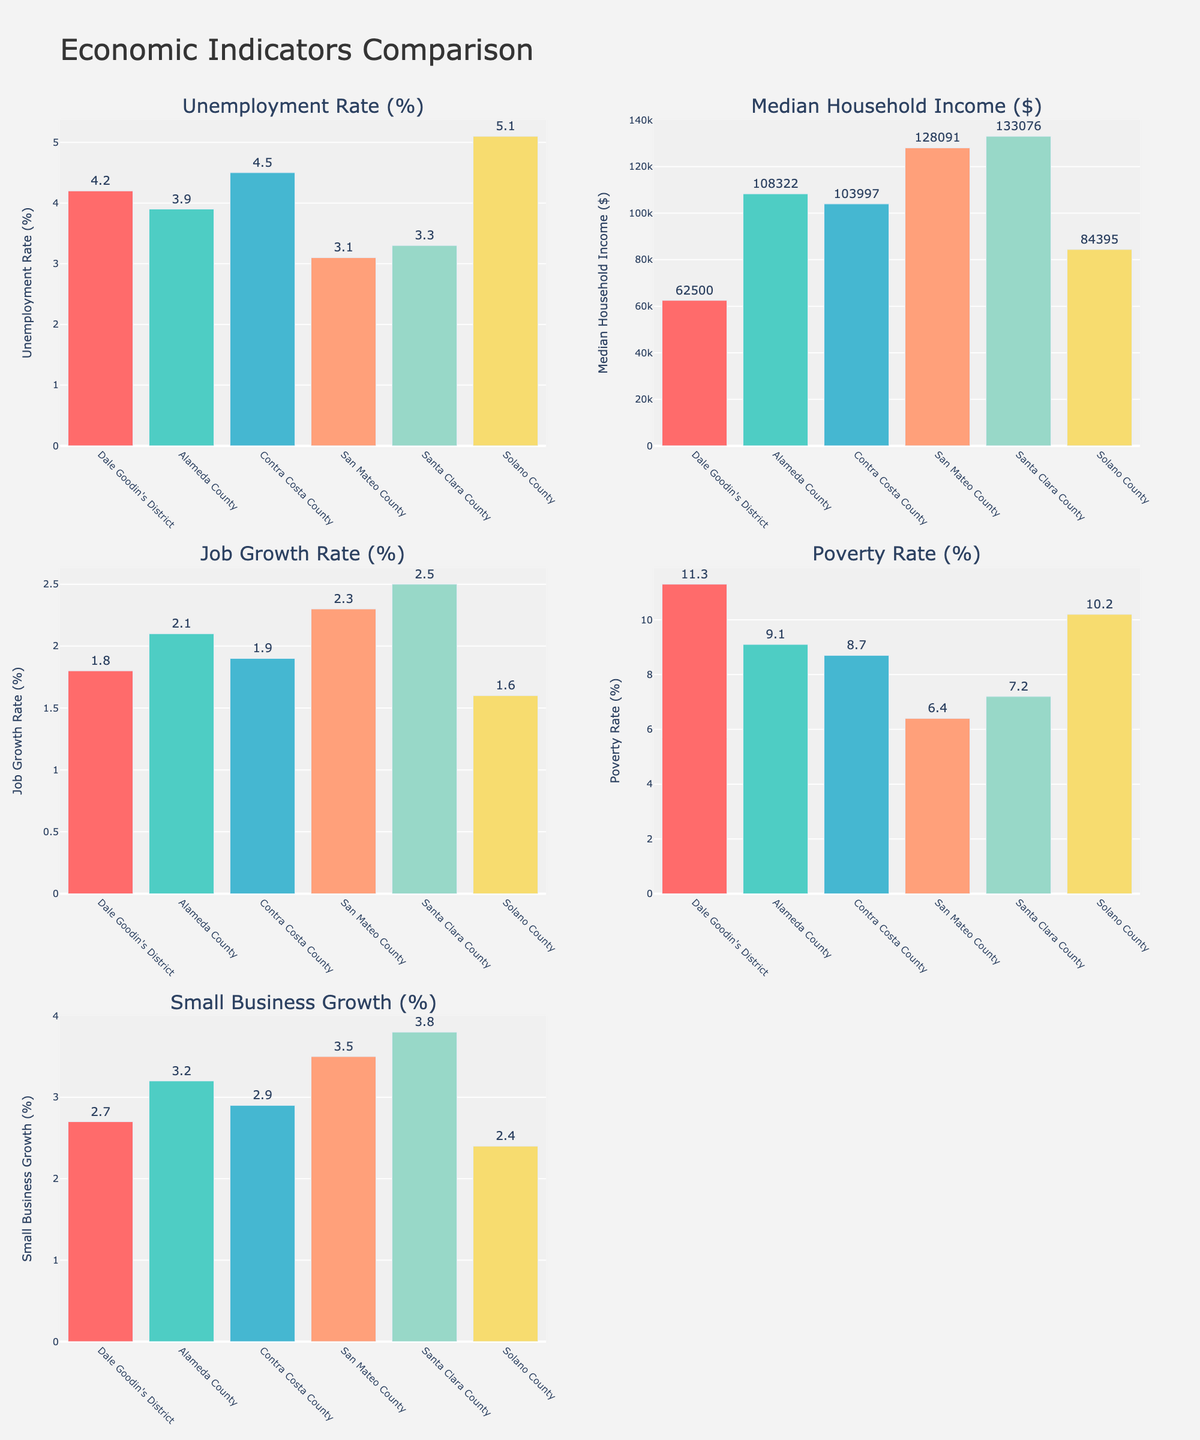what is the difference in the unemployment rate between Dale Goodin's district and Santa Clara County? To find the difference in the unemployment rate, subtract the unemployment rate of Santa Clara County (3.3%) from that of Dale Goodin's district (4.2%): 4.2 - 3.3 = 0.9%.
Answer: 0.9% Which district has the highest median household income? By comparing the median household income values, Santa Clara County has the highest value at $133,076.
Answer: Santa Clara County How does the poverty rate in Dale Goodin's district compare to Alameda County? Dale Goodin's district has a poverty rate of 11.3%, while Alameda County has a rate of 9.1%. Dale Goodin's district has a higher poverty rate by 2.2%.
Answer: Higher by 2.2% Which district has the lowest job growth rate? By looking at the job growth rates, Solano County has the lowest rate at 1.6%.
Answer: Solano County What is the combined median household income for Dale Goodin's district and Contra Costa County? The median household income for Dale Goodin's district is $62,500 and for Contra Costa County is $103,997. Adding these values gives us $62,500 + $103,997 = $166,497.
Answer: $166,497 How does the small business growth in Dale Goodin's district compare with San Mateo County? Dale Goodin's district has a small business growth of 2.7%, whereas San Mateo County has a growth of 3.5%. San Mateo County has a higher small business growth rate by 0.8%.
Answer: Higher by 0.8% What is the average unemployment rate across all districts? Adding the unemployment rates (4.2 + 3.9 + 4.5 + 3.1 + 3.3 + 5.1) and dividing by the number of districts (6), we get (24.1 / 6) = 4.02%.
Answer: 4.02% Which district exhibits the highest poverty rate and what is that rate? By comparing all districts, Dale Goodin's district exhibits the highest poverty rate at 11.3%.
Answer: Dale Goodin's district In terms of unemployment rate, which districts have rates lower than Dale Goodin’s district? Dale Goodin's district has an unemployment rate of 4.2%. The districts with lower rates are Alameda County (3.9%), San Mateo County (3.1%), and Santa Clara County (3.3%).
Answer: Alameda County, San Mateo County, Santa Clara County 